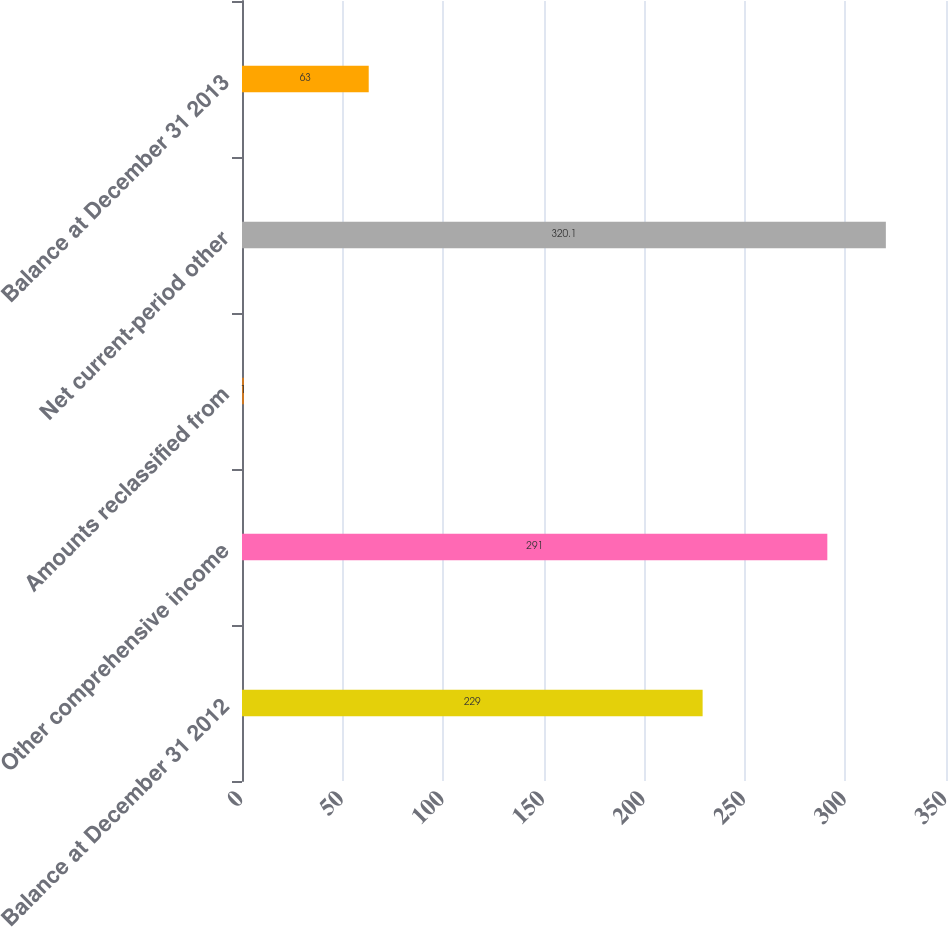<chart> <loc_0><loc_0><loc_500><loc_500><bar_chart><fcel>Balance at December 31 2012<fcel>Other comprehensive income<fcel>Amounts reclassified from<fcel>Net current-period other<fcel>Balance at December 31 2013<nl><fcel>229<fcel>291<fcel>1<fcel>320.1<fcel>63<nl></chart> 